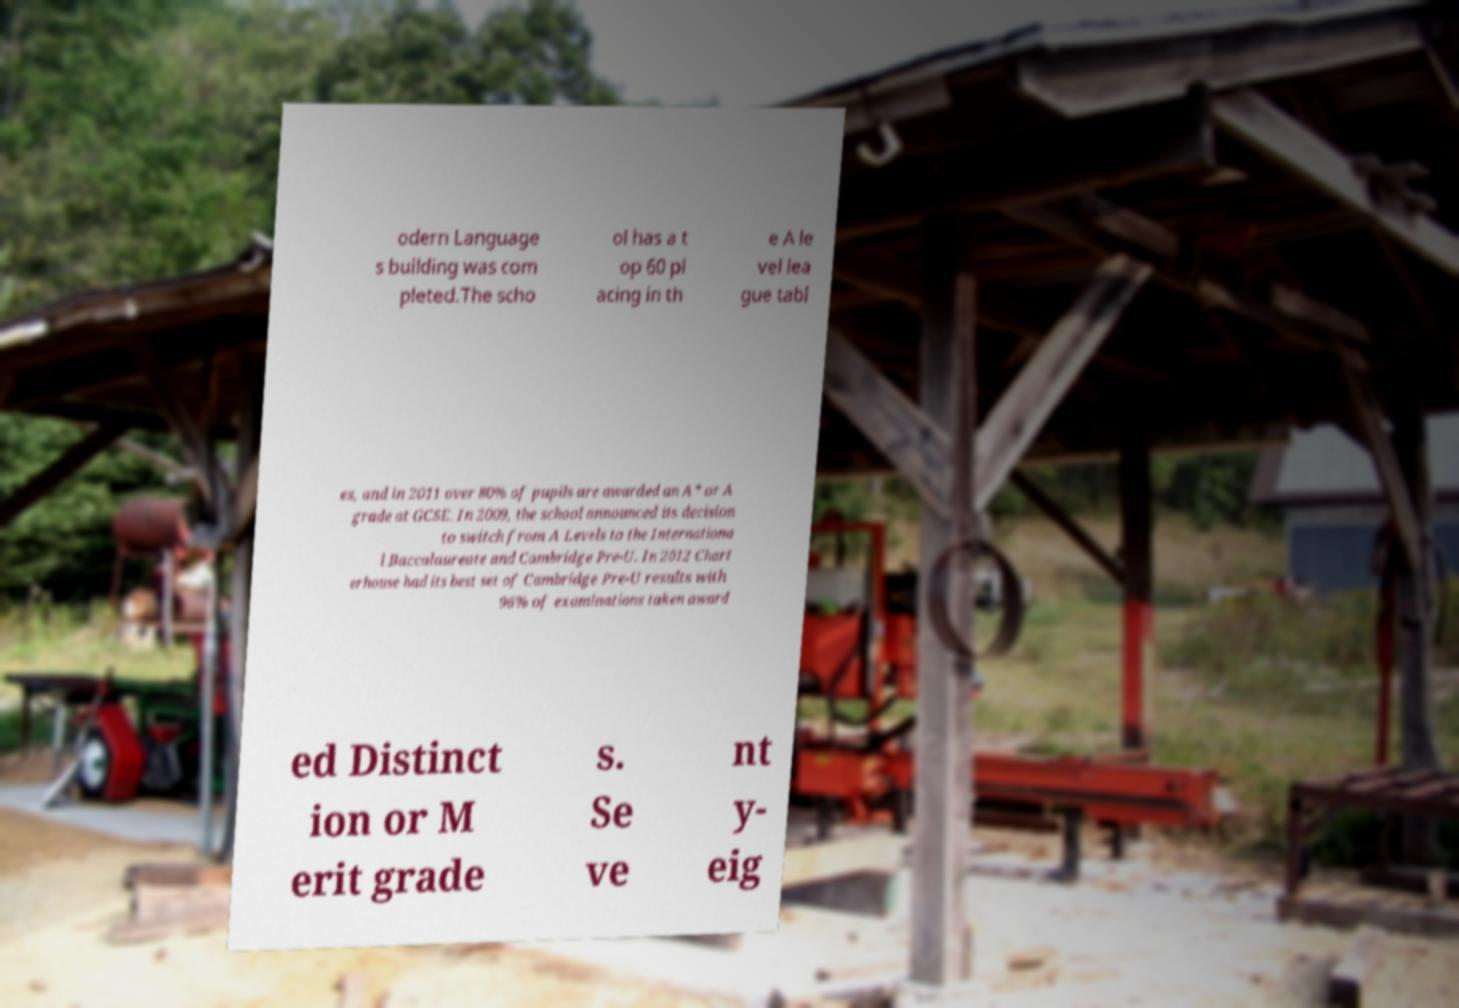Can you accurately transcribe the text from the provided image for me? odern Language s building was com pleted.The scho ol has a t op 60 pl acing in th e A le vel lea gue tabl es, and in 2011 over 80% of pupils are awarded an A* or A grade at GCSE. In 2009, the school announced its decision to switch from A Levels to the Internationa l Baccalaureate and Cambridge Pre-U. In 2012 Chart erhouse had its best set of Cambridge Pre-U results with 96% of examinations taken award ed Distinct ion or M erit grade s. Se ve nt y- eig 